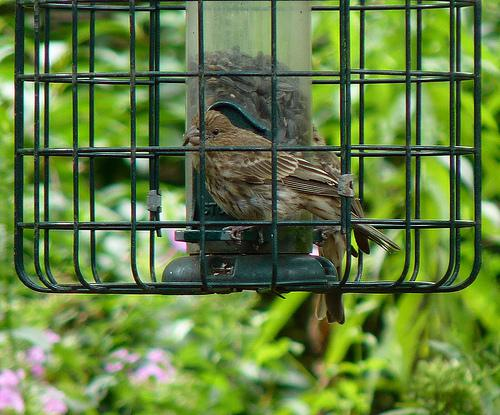Question: what is in the feeder?
Choices:
A. Oats.
B. Bird Seed.
C. Hay.
D. Grain.
Answer with the letter. Answer: B Question: how many birds?
Choices:
A. 2.
B. 5.
C. 6.
D. 7.
Answer with the letter. Answer: A Question: what are the birds resting on?
Choices:
A. The birdbath.
B. A perch.
C. A truck.
D. The fence.
Answer with the letter. Answer: B Question: where is the bird?
Choices:
A. A zoo.
B. In a tree.
C. In the air.
D. In a park.
Answer with the letter. Answer: D 